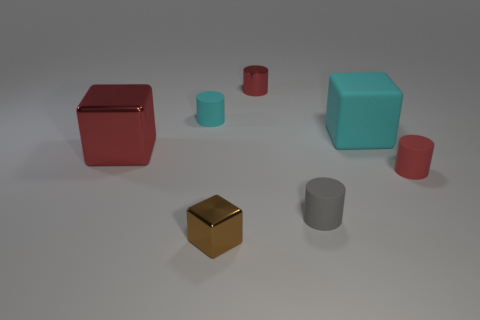There is a rubber thing that is the same color as the big metal block; what is its shape?
Offer a very short reply. Cylinder. Is there another cube that has the same material as the cyan block?
Your answer should be compact. No. There is a matte cylinder that is the same color as the rubber cube; what is its size?
Offer a very short reply. Small. There is a small cube that is on the right side of the small matte cylinder that is on the left side of the brown cube; what color is it?
Offer a terse response. Brown. Is the gray rubber object the same size as the cyan cube?
Your answer should be very brief. No. How many blocks are either red metallic things or brown metallic objects?
Make the answer very short. 2. There is a metal cube that is behind the red rubber cylinder; what number of small brown metal things are behind it?
Provide a succinct answer. 0. Is the shape of the gray rubber thing the same as the small brown thing?
Keep it short and to the point. No. The cyan thing that is the same shape as the brown metal thing is what size?
Provide a short and direct response. Large. There is a cyan matte thing that is in front of the tiny matte cylinder that is behind the big red metal thing; what is its shape?
Give a very brief answer. Cube. 